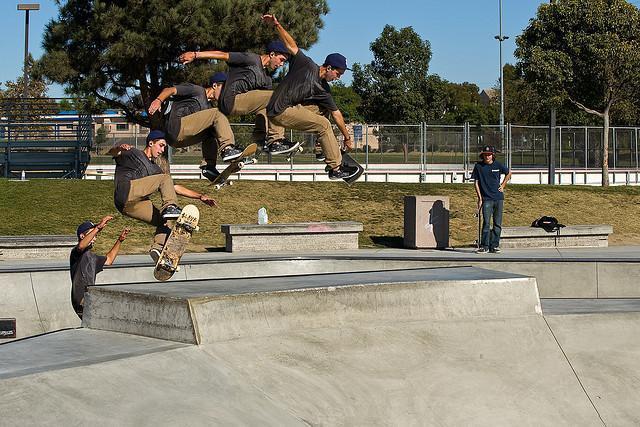How many people are skating?
Give a very brief answer. 1. How many benches are visible?
Give a very brief answer. 2. How many people are there?
Give a very brief answer. 6. How many bikes are there?
Give a very brief answer. 0. 